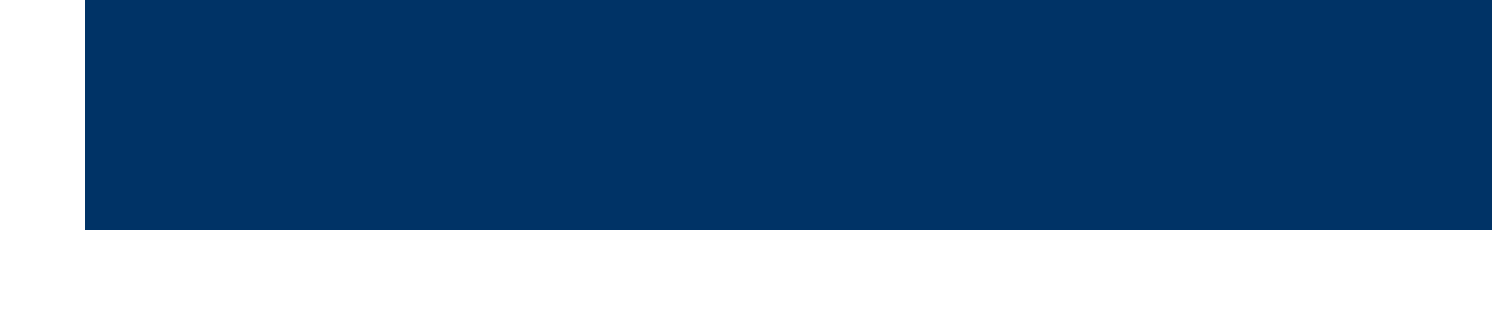what software is developed by Dlubal Software? The document mentions RWIND Simulation, which is developed by Dlubal Software for wind load analysis.
Answer: RWIND Simulation what technology does PLAXIS 3D utilize? The document states that PLAXIS 3D utilizes finite element analysis capabilities for wind turbine foundation design.
Answer: finite element analysis how much reduction in steel use was achieved by the optimization project in the North Sea? The document explicitly mentions that the resulting designs showed a 15% reduction in steel use compared to traditional methods.
Answer: 15% what is the primary focus of the WindEurope Annual Event 2023? The document indicates that the focus of the WindEurope Annual Event 2023 is on the latest computational methods for wind turbine foundation design.
Answer: computational methods who developed machine learning algorithms for foundation designs? The document specifies that the National Renewable Energy Laboratory (NREL) developed machine learning algorithms to optimize wind turbine foundation designs.
Answer: National Renewable Energy Laboratory (NREL) what is a key benefit of using WindSim's software? The document notes that one of the key benefits of WindSim's software is that it helps engineers tailor foundation designs to local conditions.
Answer: tailor foundation designs to local conditions how many days is the Offshore Wind Foundations Webinar Series scheduled for? The document specifies that the Offshore Wind Foundations Webinar Series is scheduled for five days.
Answer: five days what project did the case study focus on? The document indicates that the case study focused on a project in the North Sea for optimizing monopile foundations for a 100-turbine offshore wind farm.
Answer: monopile foundations for a 100-turbine offshore wind farm 